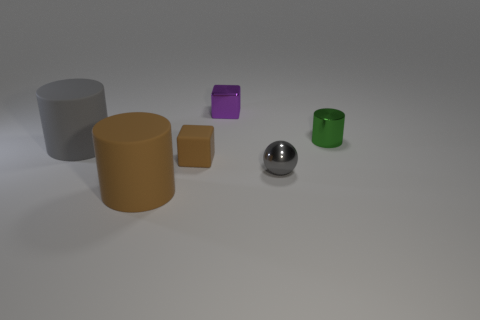Subtract all small metal cylinders. How many cylinders are left? 2 Add 4 tiny green metal objects. How many objects exist? 10 Subtract all brown cylinders. How many cylinders are left? 2 Subtract 2 cylinders. How many cylinders are left? 1 Subtract 1 brown cylinders. How many objects are left? 5 Subtract all cubes. How many objects are left? 4 Subtract all yellow cubes. Subtract all cyan cylinders. How many cubes are left? 2 Subtract all yellow cylinders. How many purple blocks are left? 1 Subtract all red cylinders. Subtract all brown blocks. How many objects are left? 5 Add 2 big things. How many big things are left? 4 